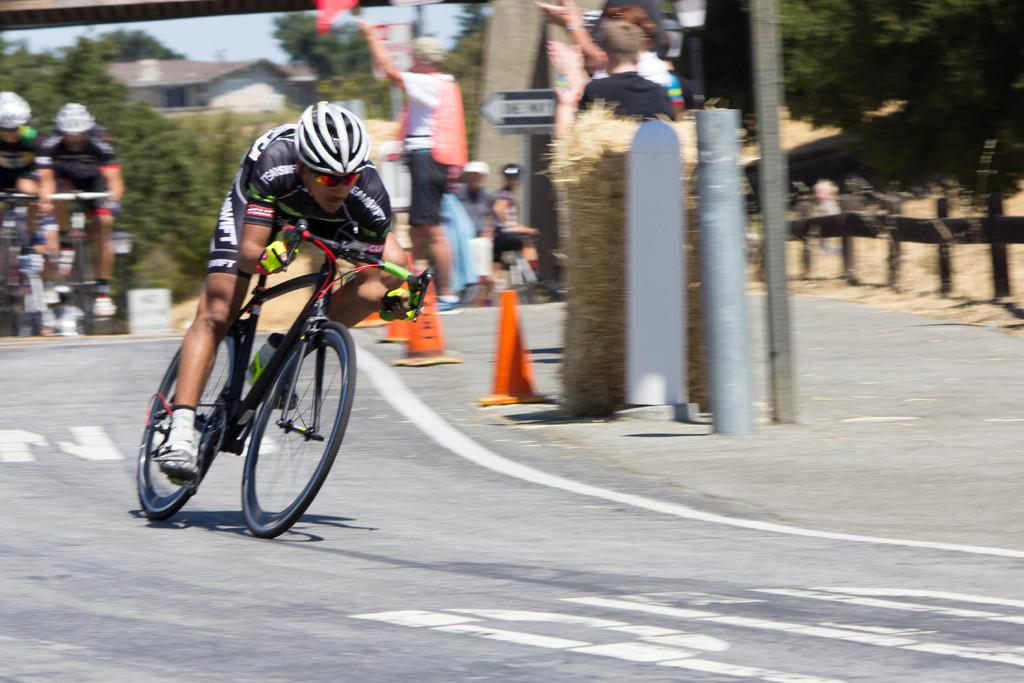What is the person in the image wearing? The person in the image is wearing a black dress. What activity is the person in the image engaged in? The person is riding a bicycle. Are there any other riders in the image? Yes, there is a group of riders behind the person. What can be seen in the right corner of the image? There is an audience in the right corner of the image. What type of sail can be seen in the image? There is no sail present in the image. Is there a kettle being used by the audience in the image? There is no kettle visible in the image. 